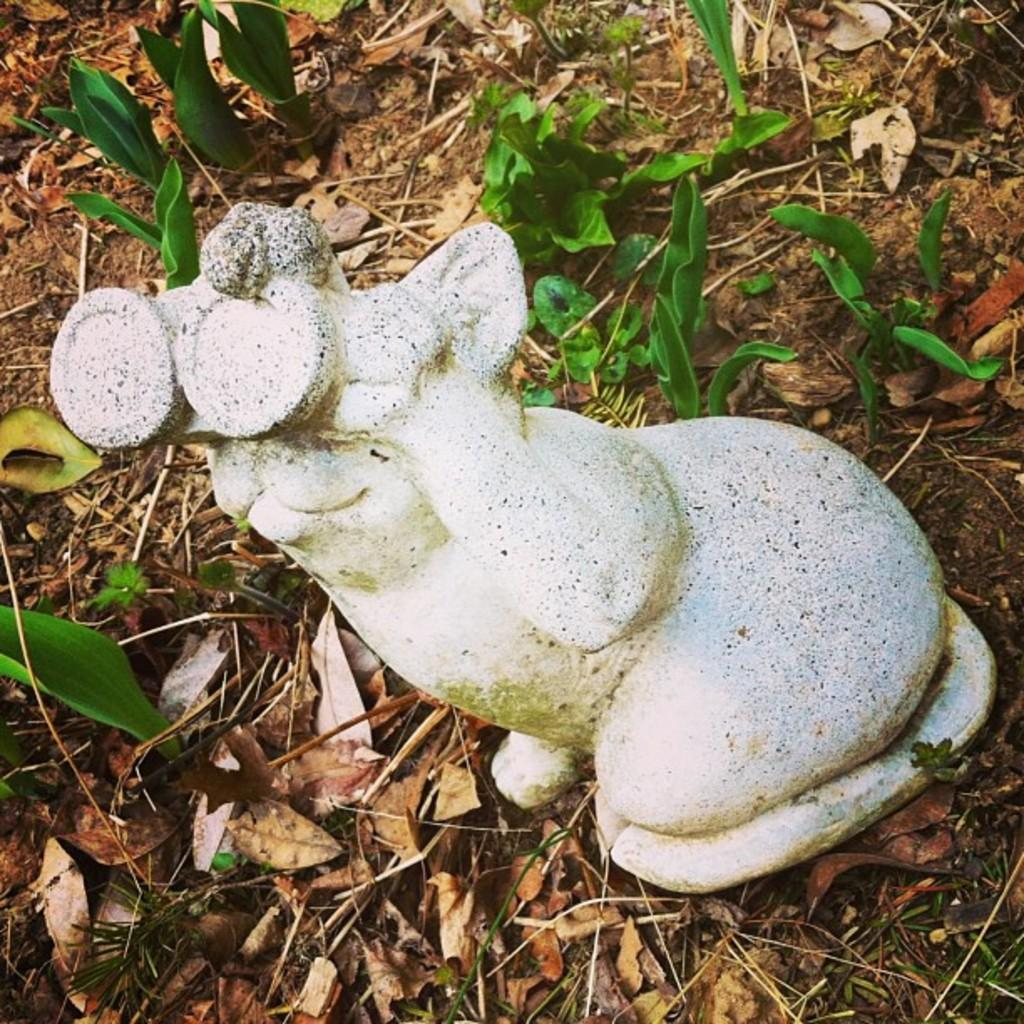What is located on the ground in the image? There is a sculpture and plants on the ground. What else can be found on the ground in the image? There are leaves on the ground. Where is the best spot to have lunch in the image? The image does not show any specific spots for having lunch, nor does it contain any references to lunch. 